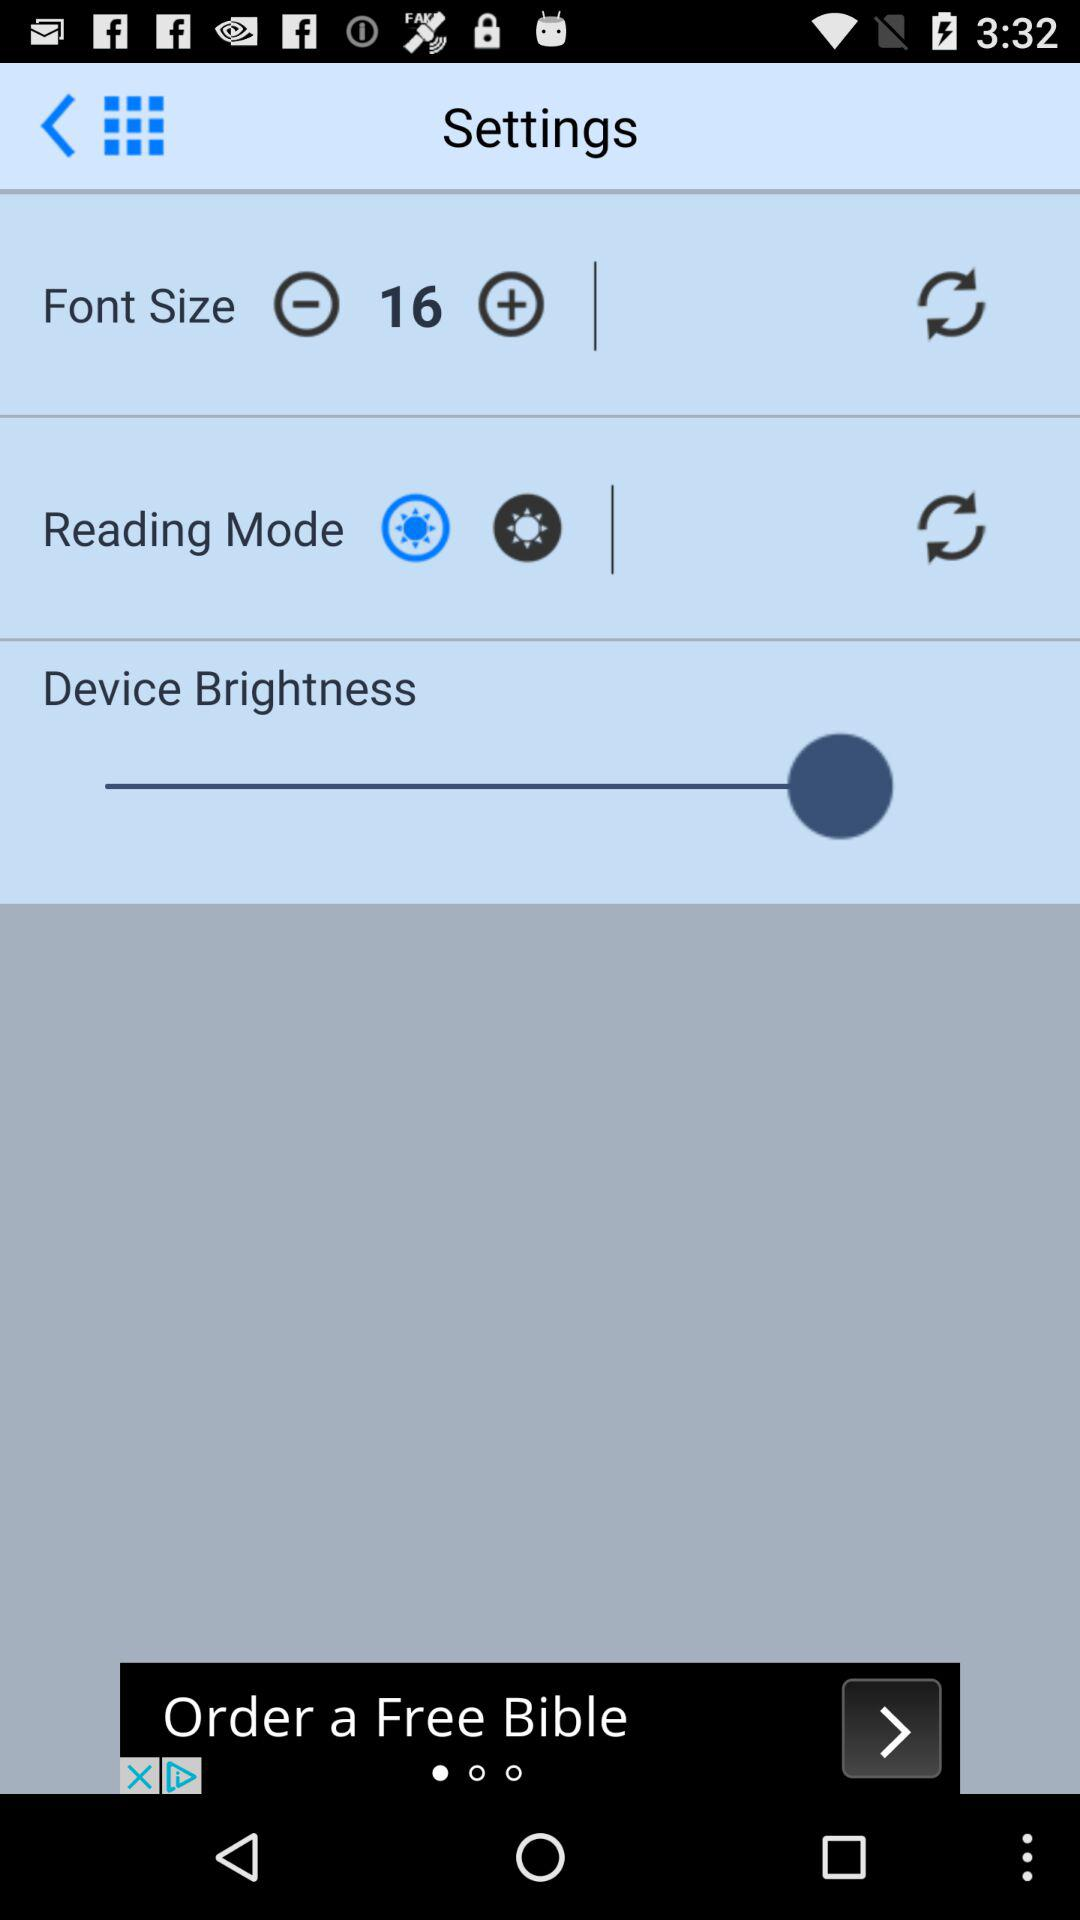What is the font size? The font size is 16. 